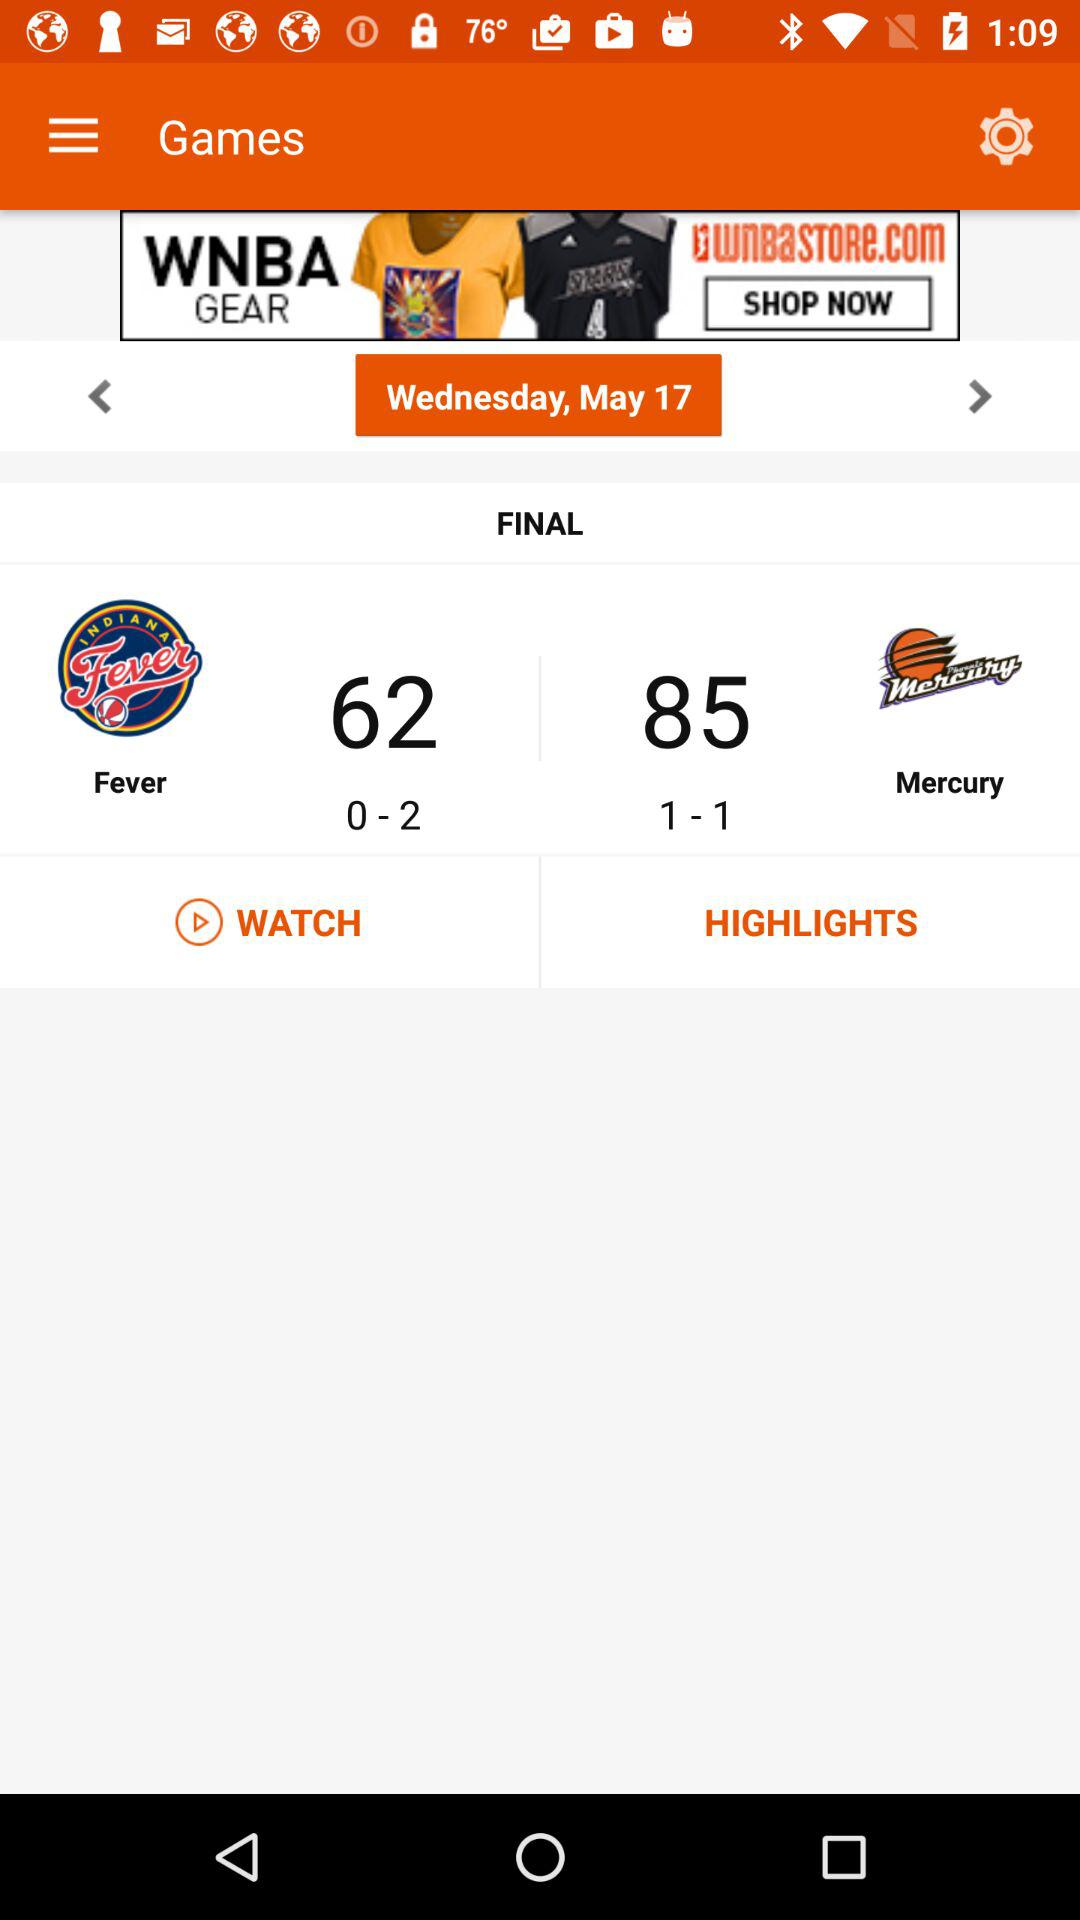What day is it on May 17? It is Wednesday on May 17. 